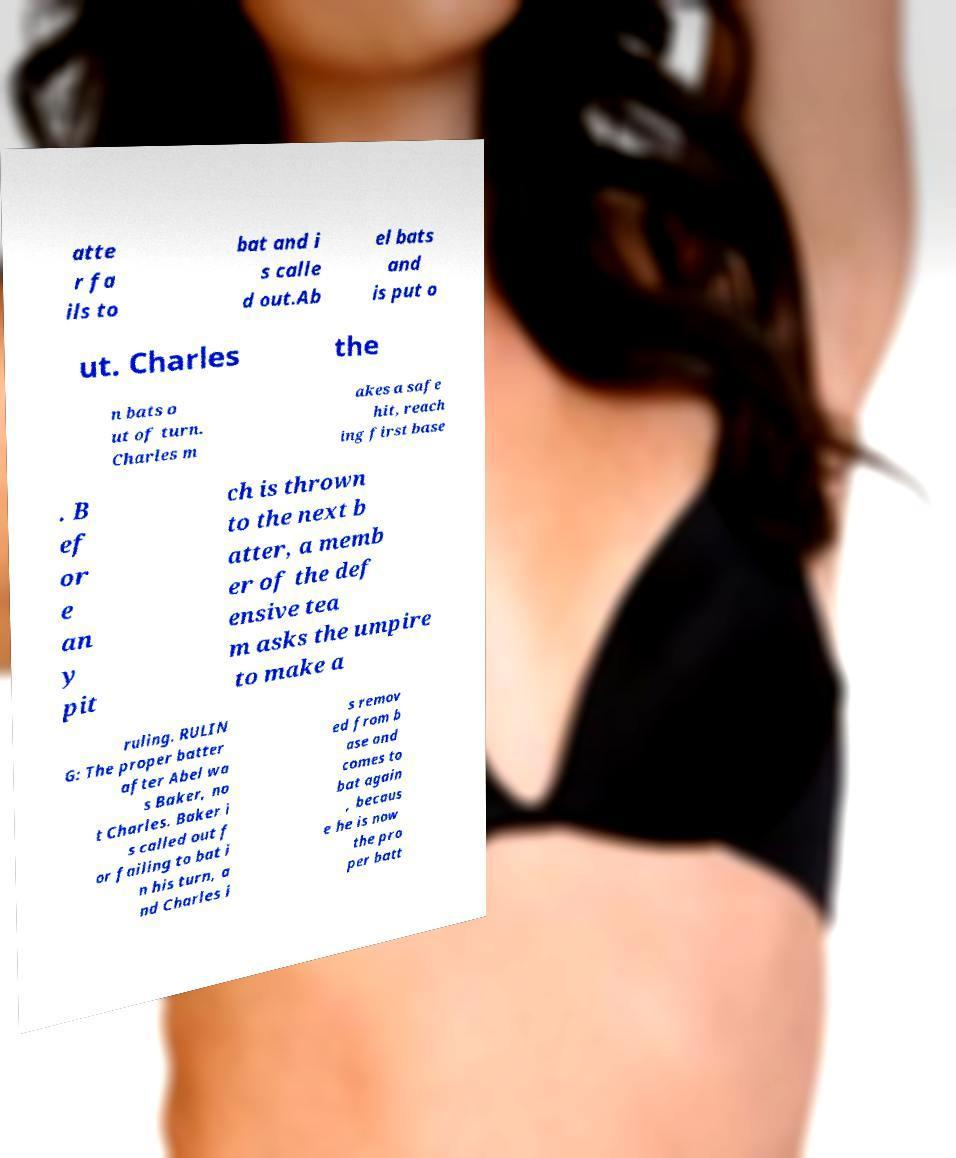Could you extract and type out the text from this image? atte r fa ils to bat and i s calle d out.Ab el bats and is put o ut. Charles the n bats o ut of turn. Charles m akes a safe hit, reach ing first base . B ef or e an y pit ch is thrown to the next b atter, a memb er of the def ensive tea m asks the umpire to make a ruling. RULIN G: The proper batter after Abel wa s Baker, no t Charles. Baker i s called out f or failing to bat i n his turn, a nd Charles i s remov ed from b ase and comes to bat again , becaus e he is now the pro per batt 